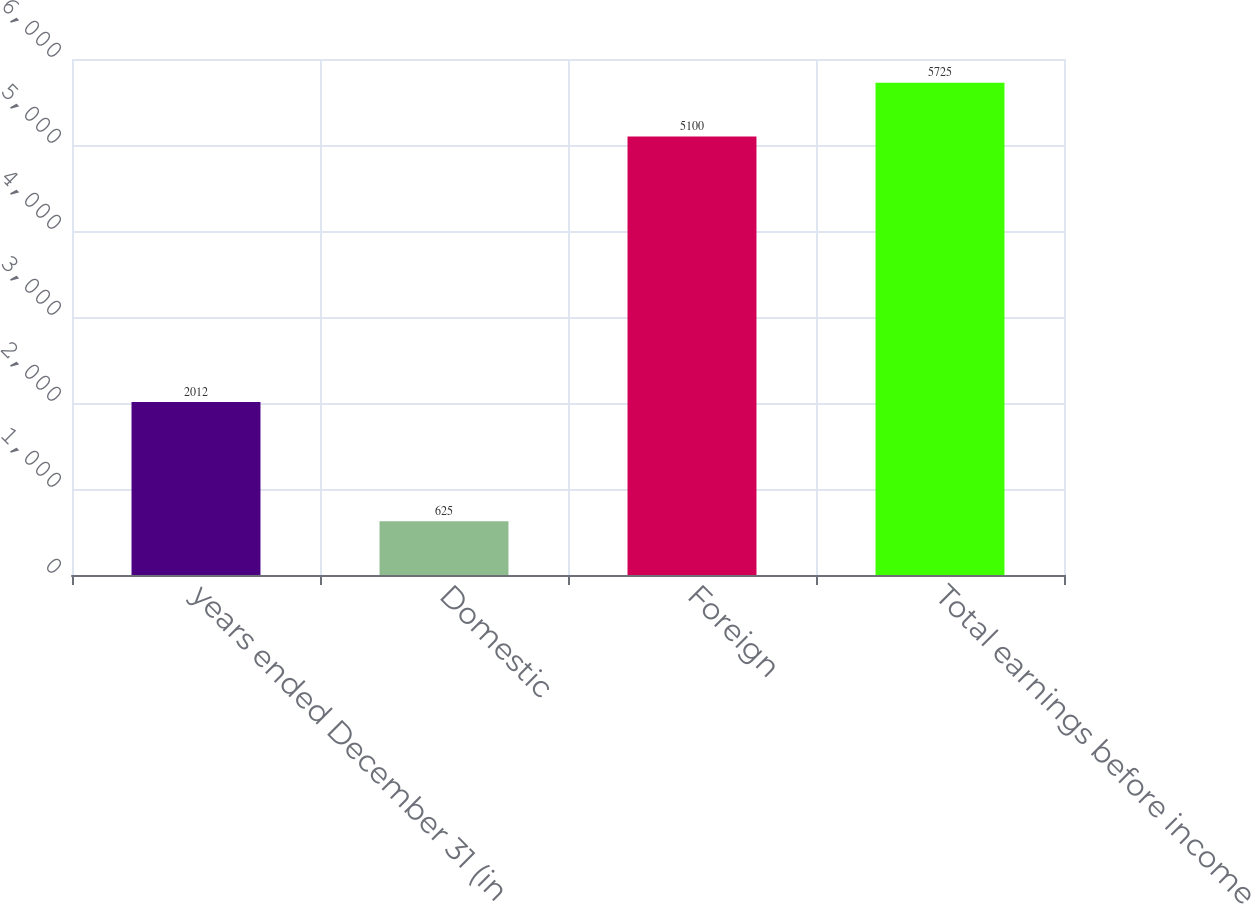Convert chart to OTSL. <chart><loc_0><loc_0><loc_500><loc_500><bar_chart><fcel>years ended December 31 (in<fcel>Domestic<fcel>Foreign<fcel>Total earnings before income<nl><fcel>2012<fcel>625<fcel>5100<fcel>5725<nl></chart> 